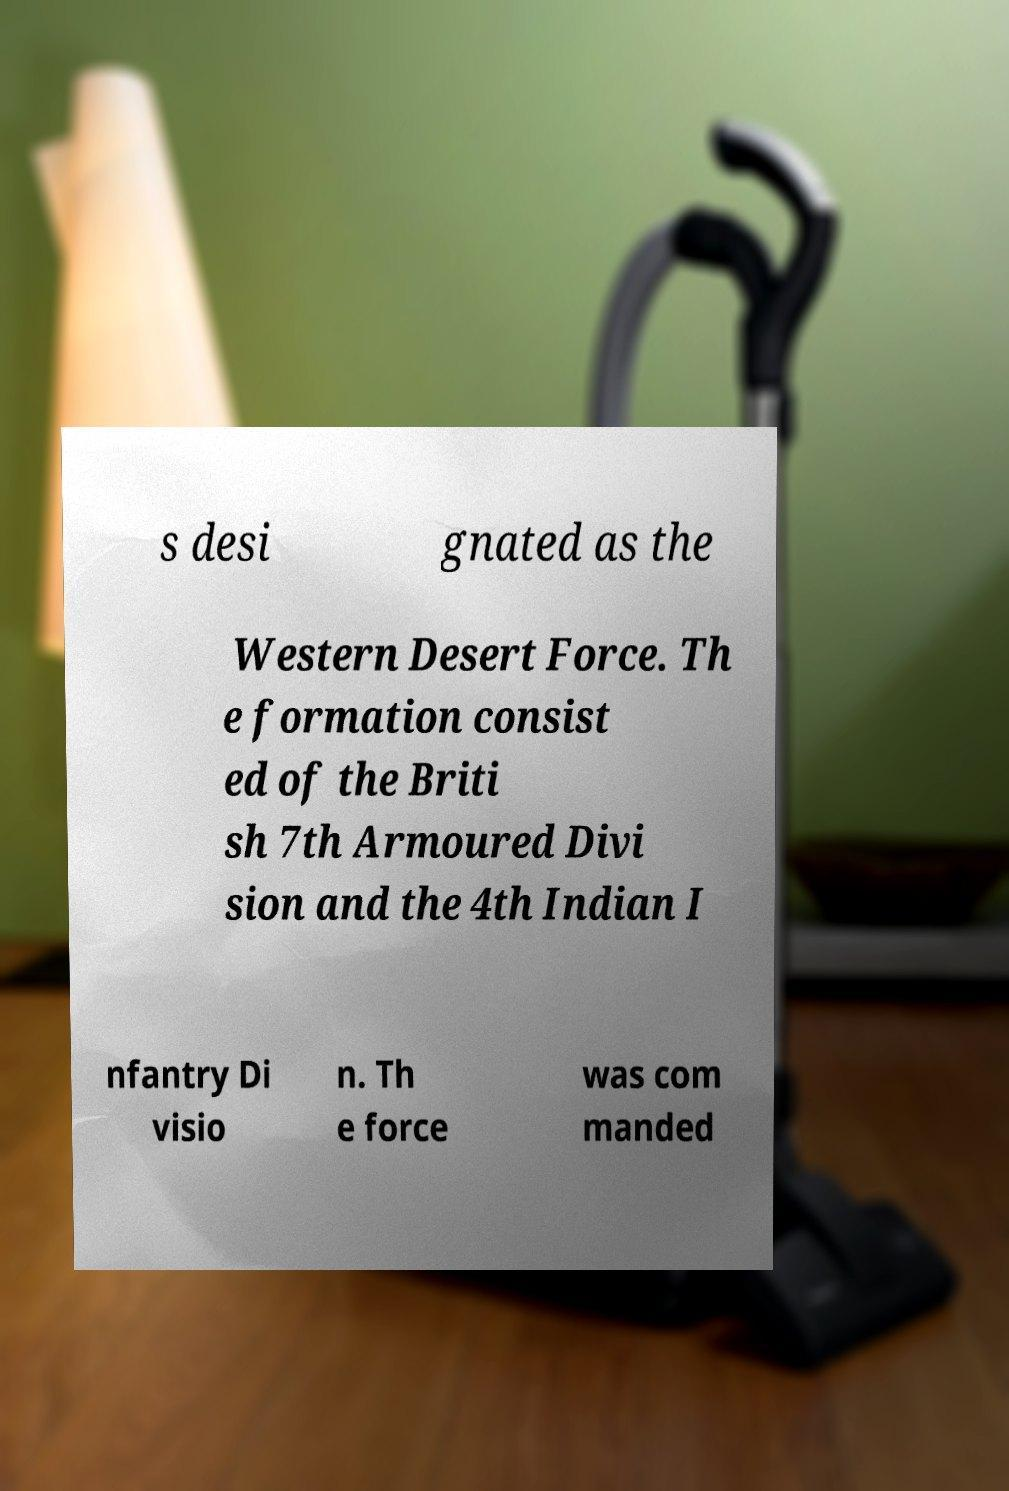Please read and relay the text visible in this image. What does it say? s desi gnated as the Western Desert Force. Th e formation consist ed of the Briti sh 7th Armoured Divi sion and the 4th Indian I nfantry Di visio n. Th e force was com manded 